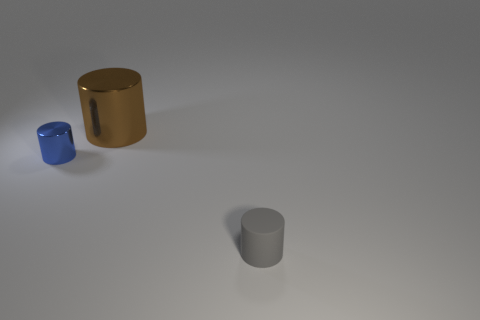What color is the rubber object that is the same shape as the big brown shiny object?
Offer a terse response. Gray. Are there more small gray objects than objects?
Provide a short and direct response. No. Does the gray cylinder have the same material as the brown cylinder?
Provide a succinct answer. No. How many blue things have the same material as the small blue cylinder?
Provide a succinct answer. 0. Do the rubber object and the shiny thing on the right side of the small blue shiny thing have the same size?
Offer a terse response. No. There is a thing that is both in front of the big shiny cylinder and left of the tiny rubber thing; what is its color?
Keep it short and to the point. Blue. Are there any large brown cylinders to the left of the thing that is in front of the tiny blue metal thing?
Give a very brief answer. Yes. Is the number of small gray things behind the blue object the same as the number of small green spheres?
Provide a short and direct response. Yes. How many shiny objects are on the left side of the small cylinder behind the small matte cylinder that is to the right of the big metallic thing?
Your answer should be very brief. 0. Are there any cyan metal things that have the same size as the gray rubber cylinder?
Provide a succinct answer. No. 